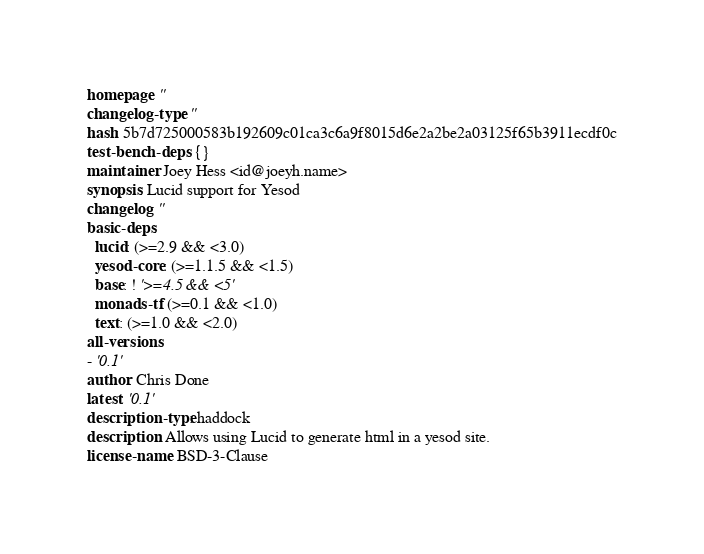<code> <loc_0><loc_0><loc_500><loc_500><_YAML_>homepage: ''
changelog-type: ''
hash: 5b7d725000583b192609c01ca3c6a9f8015d6e2a2be2a03125f65b3911ecdf0c
test-bench-deps: {}
maintainer: Joey Hess <id@joeyh.name>
synopsis: Lucid support for Yesod
changelog: ''
basic-deps:
  lucid: (>=2.9 && <3.0)
  yesod-core: (>=1.1.5 && <1.5)
  base: ! '>=4.5 && <5'
  monads-tf: (>=0.1 && <1.0)
  text: (>=1.0 && <2.0)
all-versions:
- '0.1'
author: Chris Done
latest: '0.1'
description-type: haddock
description: Allows using Lucid to generate html in a yesod site.
license-name: BSD-3-Clause
</code> 